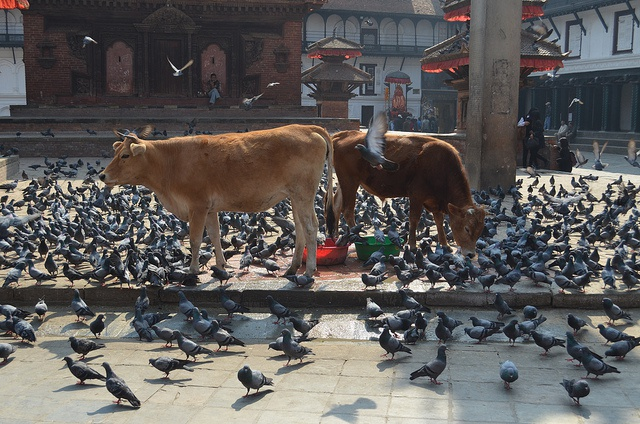Describe the objects in this image and their specific colors. I can see bird in salmon, black, gray, and darkgray tones, cow in salmon, maroon, and gray tones, cow in salmon, black, gray, and maroon tones, people in salmon, black, and gray tones, and bird in salmon, black, and gray tones in this image. 